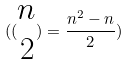Convert formula to latex. <formula><loc_0><loc_0><loc_500><loc_500>( ( \begin{matrix} n \\ 2 \end{matrix} ) = \frac { n ^ { 2 } - n } { 2 } )</formula> 